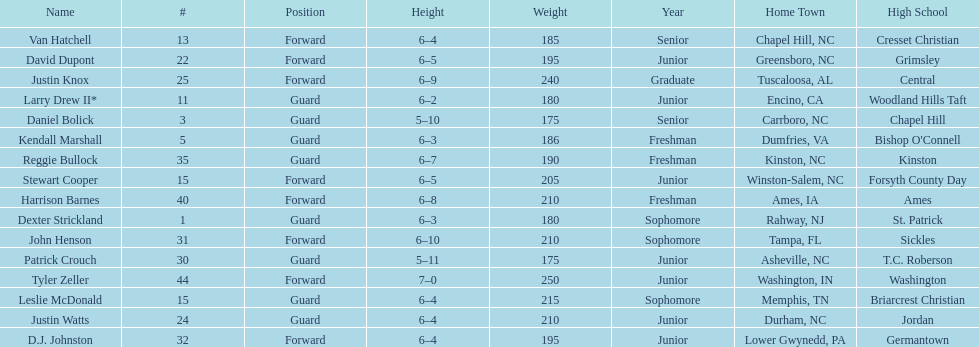What is the number of players with a weight over 200? 7. 